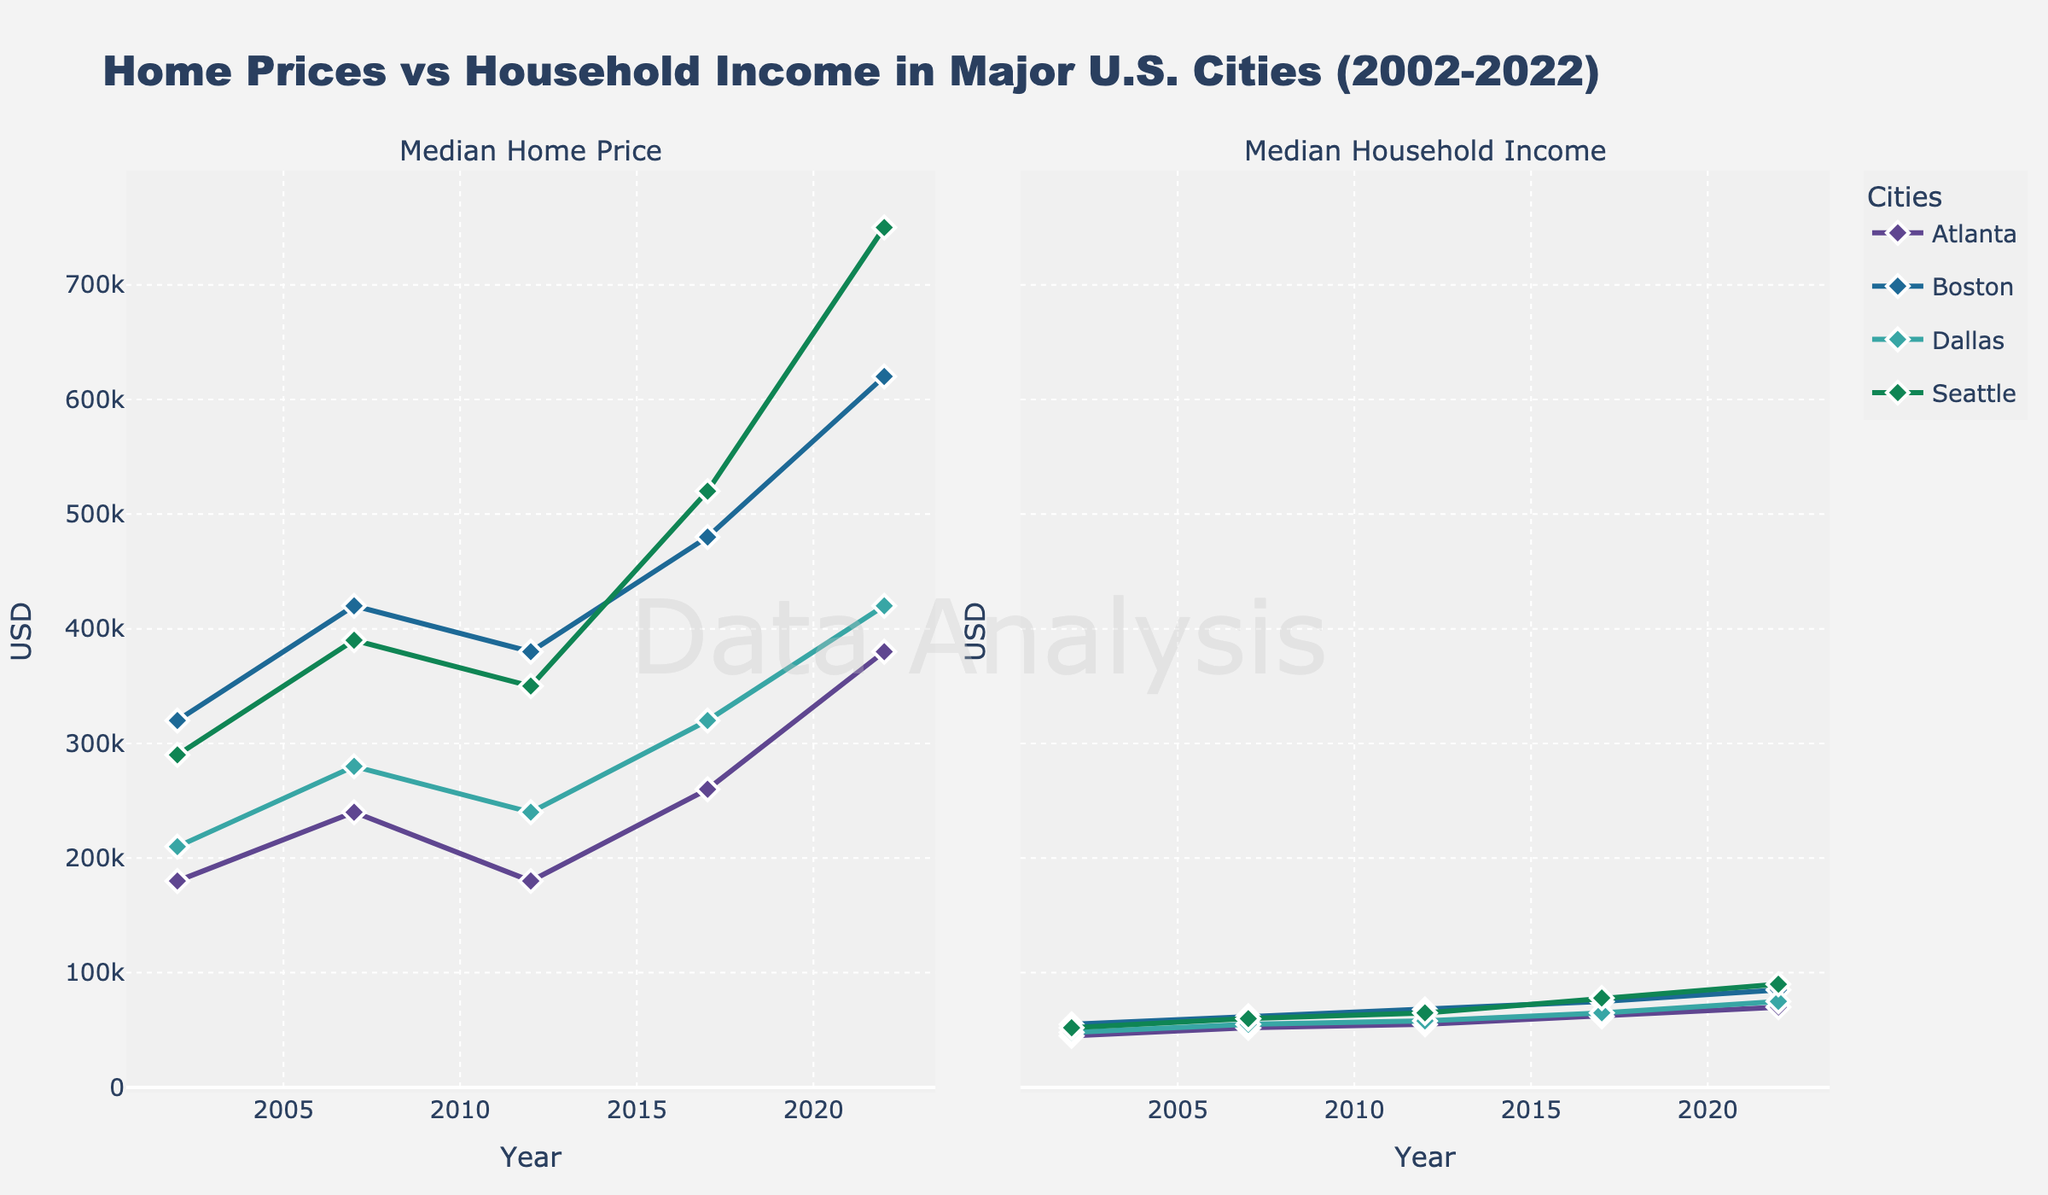What's the trend in median home prices in Boston from 2002 to 2022? Observing the line chart for Median Home Price in Boston, one can see the price increased from $320,000 in 2002 to $620,000 in 2022, showing an upward trend over the years.
Answer: Upward trend How does the median household income in Dallas compare to Seattle in 2022? Referring to the line chart for Median Household Income, in 2022, Dallas has an income of $75,000 and Seattle has $90,000. Comparing these values, Seattle’s income is higher.
Answer: Seattle's income is higher Which city had the lowest median home price in 2012? Checking the median home price for all cities in 2012, Atlanta had the lowest price at $180,000.
Answer: Atlanta What was the percentage increase in median home prices in Atlanta from 2002 to 2022? From the chart, the median home price in Atlanta rose from $180,000 in 2002 to $380,000 in 2022. The percentage increase is calculated as ((380000 - 180000) / 180000) * 100 = 111.11%.
Answer: 111.11% What is the difference in household income between the highest and lowest income cities in 2022? In 2022, Seattle has the highest median household income ($90,000) and Atlanta has the lowest ($70,000). The difference is $90,000 - $70,000 = $20,000.
Answer: $20,000 Which city showed the most significant increase in median home prices between 2017 and 2022? Observing the chart data, Seattle's home prices increased from $520,000 in 2017 to $750,000 in 2022, an increase of $230,000, which is the most significant among all cities.
Answer: Seattle What was the median household income in Boston in 2007 compared to 2017? The chart for Median Household Income shows Boston’s income in 2007 was $62,000, and in 2017 it was $75,000.
Answer: $62,000 in 2007 and $75,000 in 2017 Did any city show a decrease in median home prices between 2007 and 2012? According to the median home price chart, Atlanta's home price decreased from $240,000 in 2007 to $180,000 in 2012.
Answer: Atlanta What's the average median household income in Seattle over the years 2002, 2007, 2012, 2017, and 2022? Adding the household incomes of Seattle for the mentioned years ($52,000, $60,000, $65,000, $78,000, $90,000) and dividing by 5 gives the average: (52000 + 60000 + 65000 + 78000 + 90000) / 5 = $67,000.
Answer: $67,000 